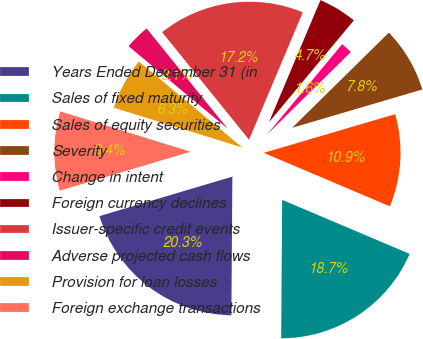Convert chart. <chart><loc_0><loc_0><loc_500><loc_500><pie_chart><fcel>Years Ended December 31 (in<fcel>Sales of fixed maturity<fcel>Sales of equity securities<fcel>Severity<fcel>Change in intent<fcel>Foreign currency declines<fcel>Issuer-specific credit events<fcel>Adverse projected cash flows<fcel>Provision for loan losses<fcel>Foreign exchange transactions<nl><fcel>20.3%<fcel>18.74%<fcel>10.94%<fcel>7.82%<fcel>1.58%<fcel>4.7%<fcel>17.18%<fcel>3.14%<fcel>6.26%<fcel>9.38%<nl></chart> 